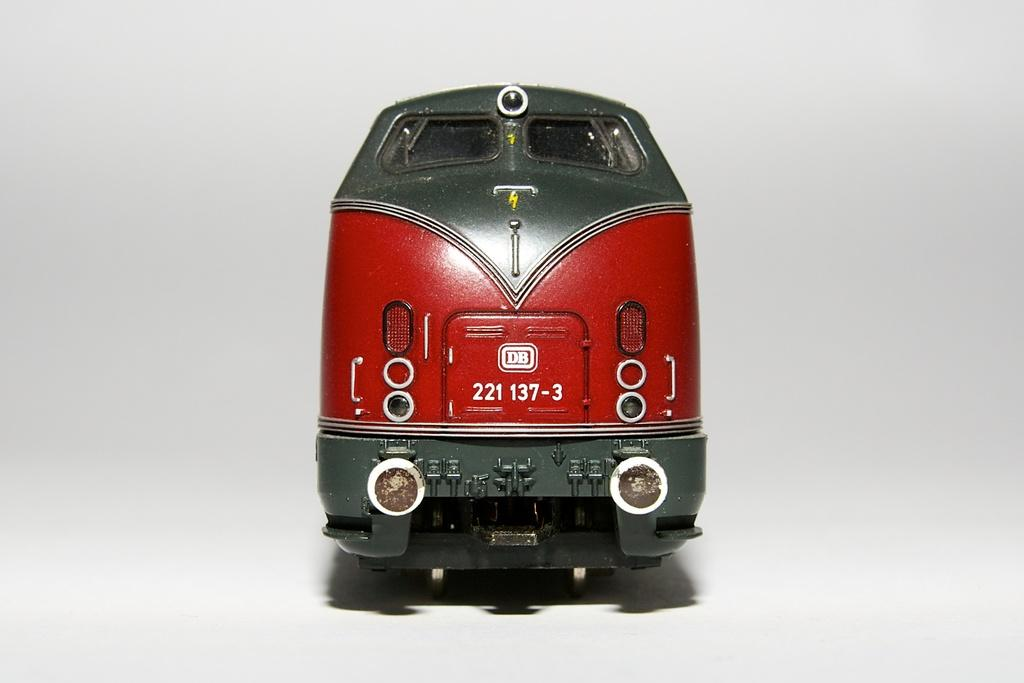What is the main subject of the image? The main subject of the image is a train. Can you describe the colors of the train? The train has red, green, and white colors. What is the color of the background in the image? The background of the image is white. How many roses can be seen growing near the train in the image? There are no roses present in the image; it features a train with a white background. 